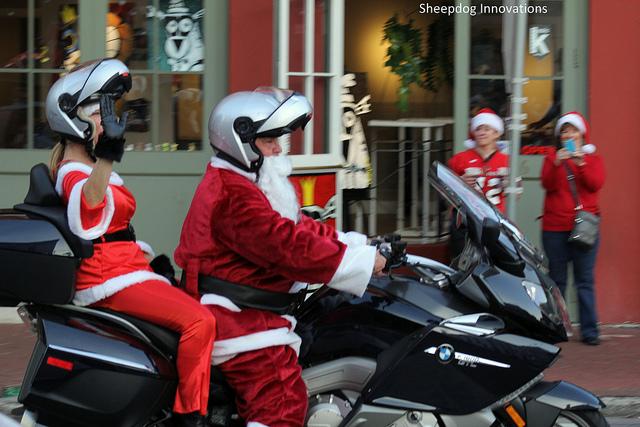How many people are on the motorcycle?
Short answer required. 2. Who is the motorcycle driver dressed as?
Concise answer only. Santa. Is the woman wearing jeans?
Give a very brief answer. No. What is the lady riding?
Give a very brief answer. Motorcycle. What color is the woman's jacket?
Concise answer only. Red. How many people can be seen?
Short answer required. 4. 